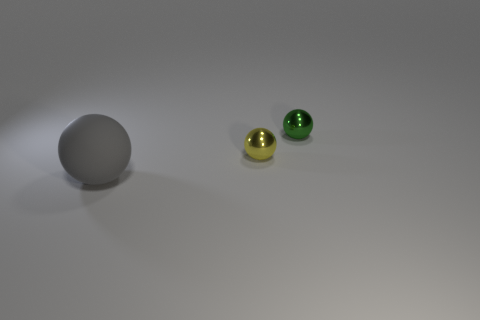Are there fewer small objects that are to the left of the yellow sphere than big things on the left side of the big gray sphere?
Your answer should be very brief. No. Are there any other things of the same color as the big matte sphere?
Give a very brief answer. No. The green metal thing is what shape?
Your answer should be compact. Sphere. What color is the other thing that is the same material as the green thing?
Your answer should be compact. Yellow. Are there more big red objects than tiny green spheres?
Keep it short and to the point. No. Is there a shiny sphere?
Ensure brevity in your answer.  Yes. What shape is the metallic thing on the left side of the shiny object that is right of the small yellow metal thing?
Your response must be concise. Sphere. What number of things are either tiny green spheres or balls that are on the left side of the green metal sphere?
Keep it short and to the point. 3. What color is the tiny metallic ball on the left side of the sphere right of the tiny metallic ball that is to the left of the tiny green metallic ball?
Give a very brief answer. Yellow. What material is the big thing that is the same shape as the small green shiny thing?
Keep it short and to the point. Rubber. 